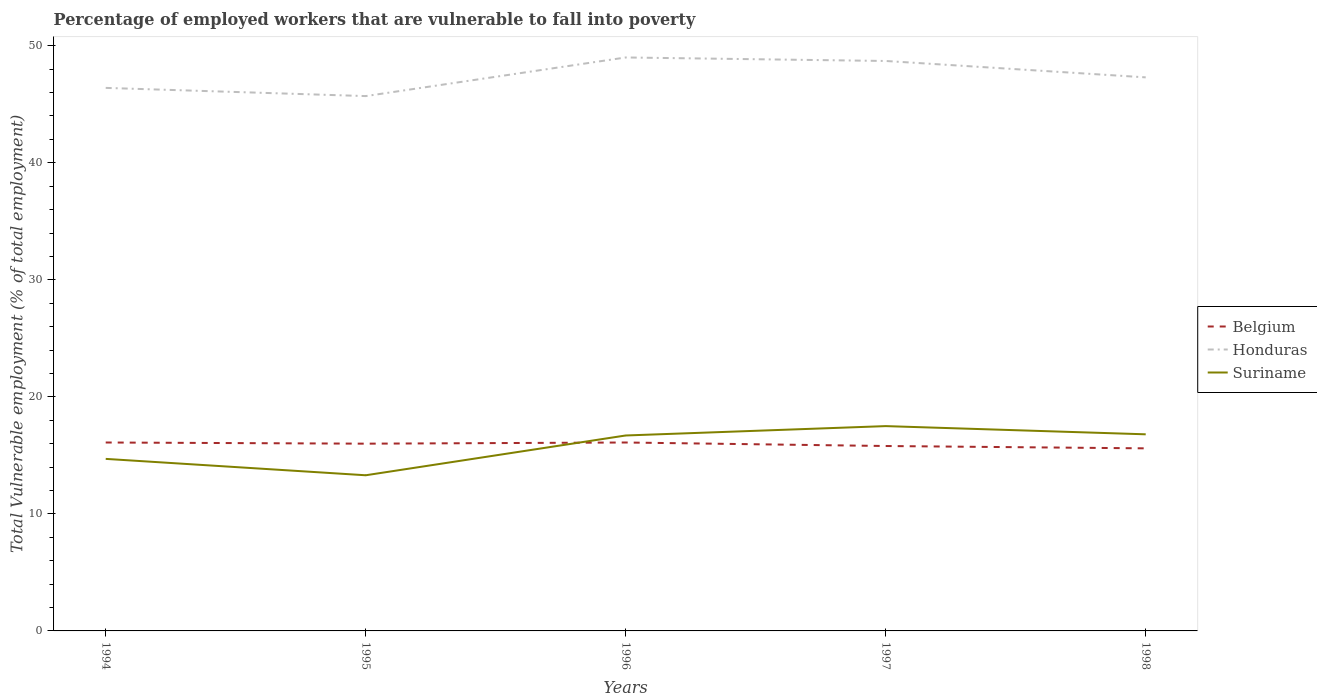How many different coloured lines are there?
Offer a terse response. 3. Is the number of lines equal to the number of legend labels?
Offer a very short reply. Yes. Across all years, what is the maximum percentage of employed workers who are vulnerable to fall into poverty in Belgium?
Give a very brief answer. 15.6. What is the total percentage of employed workers who are vulnerable to fall into poverty in Belgium in the graph?
Offer a terse response. 0.2. What is the difference between the highest and the second highest percentage of employed workers who are vulnerable to fall into poverty in Suriname?
Your response must be concise. 4.2. What is the difference between the highest and the lowest percentage of employed workers who are vulnerable to fall into poverty in Suriname?
Ensure brevity in your answer.  3. Is the percentage of employed workers who are vulnerable to fall into poverty in Suriname strictly greater than the percentage of employed workers who are vulnerable to fall into poverty in Honduras over the years?
Your answer should be compact. Yes. How many years are there in the graph?
Make the answer very short. 5. What is the difference between two consecutive major ticks on the Y-axis?
Provide a succinct answer. 10. Are the values on the major ticks of Y-axis written in scientific E-notation?
Give a very brief answer. No. Does the graph contain any zero values?
Offer a very short reply. No. Does the graph contain grids?
Your response must be concise. No. What is the title of the graph?
Give a very brief answer. Percentage of employed workers that are vulnerable to fall into poverty. Does "Turkmenistan" appear as one of the legend labels in the graph?
Ensure brevity in your answer.  No. What is the label or title of the Y-axis?
Offer a very short reply. Total Vulnerable employment (% of total employment). What is the Total Vulnerable employment (% of total employment) of Belgium in 1994?
Give a very brief answer. 16.1. What is the Total Vulnerable employment (% of total employment) of Honduras in 1994?
Give a very brief answer. 46.4. What is the Total Vulnerable employment (% of total employment) of Suriname in 1994?
Make the answer very short. 14.7. What is the Total Vulnerable employment (% of total employment) in Honduras in 1995?
Provide a succinct answer. 45.7. What is the Total Vulnerable employment (% of total employment) of Suriname in 1995?
Ensure brevity in your answer.  13.3. What is the Total Vulnerable employment (% of total employment) in Belgium in 1996?
Provide a short and direct response. 16.1. What is the Total Vulnerable employment (% of total employment) in Honduras in 1996?
Your answer should be compact. 49. What is the Total Vulnerable employment (% of total employment) of Suriname in 1996?
Make the answer very short. 16.7. What is the Total Vulnerable employment (% of total employment) of Belgium in 1997?
Your response must be concise. 15.8. What is the Total Vulnerable employment (% of total employment) of Honduras in 1997?
Ensure brevity in your answer.  48.7. What is the Total Vulnerable employment (% of total employment) of Belgium in 1998?
Keep it short and to the point. 15.6. What is the Total Vulnerable employment (% of total employment) of Honduras in 1998?
Your response must be concise. 47.3. What is the Total Vulnerable employment (% of total employment) in Suriname in 1998?
Offer a terse response. 16.8. Across all years, what is the maximum Total Vulnerable employment (% of total employment) in Belgium?
Provide a succinct answer. 16.1. Across all years, what is the maximum Total Vulnerable employment (% of total employment) in Honduras?
Provide a short and direct response. 49. Across all years, what is the minimum Total Vulnerable employment (% of total employment) in Belgium?
Your answer should be compact. 15.6. Across all years, what is the minimum Total Vulnerable employment (% of total employment) in Honduras?
Provide a succinct answer. 45.7. Across all years, what is the minimum Total Vulnerable employment (% of total employment) of Suriname?
Give a very brief answer. 13.3. What is the total Total Vulnerable employment (% of total employment) in Belgium in the graph?
Your answer should be very brief. 79.6. What is the total Total Vulnerable employment (% of total employment) in Honduras in the graph?
Make the answer very short. 237.1. What is the total Total Vulnerable employment (% of total employment) of Suriname in the graph?
Offer a terse response. 79. What is the difference between the Total Vulnerable employment (% of total employment) of Suriname in 1994 and that in 1995?
Offer a terse response. 1.4. What is the difference between the Total Vulnerable employment (% of total employment) of Belgium in 1994 and that in 1996?
Give a very brief answer. 0. What is the difference between the Total Vulnerable employment (% of total employment) in Suriname in 1994 and that in 1997?
Your response must be concise. -2.8. What is the difference between the Total Vulnerable employment (% of total employment) of Belgium in 1994 and that in 1998?
Keep it short and to the point. 0.5. What is the difference between the Total Vulnerable employment (% of total employment) in Honduras in 1995 and that in 1996?
Ensure brevity in your answer.  -3.3. What is the difference between the Total Vulnerable employment (% of total employment) of Suriname in 1995 and that in 1996?
Ensure brevity in your answer.  -3.4. What is the difference between the Total Vulnerable employment (% of total employment) of Belgium in 1995 and that in 1997?
Offer a terse response. 0.2. What is the difference between the Total Vulnerable employment (% of total employment) in Suriname in 1995 and that in 1997?
Offer a terse response. -4.2. What is the difference between the Total Vulnerable employment (% of total employment) in Belgium in 1996 and that in 1997?
Keep it short and to the point. 0.3. What is the difference between the Total Vulnerable employment (% of total employment) of Suriname in 1996 and that in 1997?
Your answer should be very brief. -0.8. What is the difference between the Total Vulnerable employment (% of total employment) of Belgium in 1996 and that in 1998?
Provide a succinct answer. 0.5. What is the difference between the Total Vulnerable employment (% of total employment) in Honduras in 1996 and that in 1998?
Provide a succinct answer. 1.7. What is the difference between the Total Vulnerable employment (% of total employment) of Suriname in 1996 and that in 1998?
Give a very brief answer. -0.1. What is the difference between the Total Vulnerable employment (% of total employment) of Honduras in 1997 and that in 1998?
Keep it short and to the point. 1.4. What is the difference between the Total Vulnerable employment (% of total employment) in Suriname in 1997 and that in 1998?
Give a very brief answer. 0.7. What is the difference between the Total Vulnerable employment (% of total employment) in Belgium in 1994 and the Total Vulnerable employment (% of total employment) in Honduras in 1995?
Provide a short and direct response. -29.6. What is the difference between the Total Vulnerable employment (% of total employment) in Belgium in 1994 and the Total Vulnerable employment (% of total employment) in Suriname in 1995?
Keep it short and to the point. 2.8. What is the difference between the Total Vulnerable employment (% of total employment) in Honduras in 1994 and the Total Vulnerable employment (% of total employment) in Suriname in 1995?
Make the answer very short. 33.1. What is the difference between the Total Vulnerable employment (% of total employment) of Belgium in 1994 and the Total Vulnerable employment (% of total employment) of Honduras in 1996?
Your response must be concise. -32.9. What is the difference between the Total Vulnerable employment (% of total employment) of Belgium in 1994 and the Total Vulnerable employment (% of total employment) of Suriname in 1996?
Ensure brevity in your answer.  -0.6. What is the difference between the Total Vulnerable employment (% of total employment) of Honduras in 1994 and the Total Vulnerable employment (% of total employment) of Suriname in 1996?
Keep it short and to the point. 29.7. What is the difference between the Total Vulnerable employment (% of total employment) in Belgium in 1994 and the Total Vulnerable employment (% of total employment) in Honduras in 1997?
Keep it short and to the point. -32.6. What is the difference between the Total Vulnerable employment (% of total employment) of Belgium in 1994 and the Total Vulnerable employment (% of total employment) of Suriname in 1997?
Provide a short and direct response. -1.4. What is the difference between the Total Vulnerable employment (% of total employment) of Honduras in 1994 and the Total Vulnerable employment (% of total employment) of Suriname in 1997?
Provide a succinct answer. 28.9. What is the difference between the Total Vulnerable employment (% of total employment) in Belgium in 1994 and the Total Vulnerable employment (% of total employment) in Honduras in 1998?
Offer a terse response. -31.2. What is the difference between the Total Vulnerable employment (% of total employment) in Honduras in 1994 and the Total Vulnerable employment (% of total employment) in Suriname in 1998?
Your answer should be compact. 29.6. What is the difference between the Total Vulnerable employment (% of total employment) of Belgium in 1995 and the Total Vulnerable employment (% of total employment) of Honduras in 1996?
Your answer should be compact. -33. What is the difference between the Total Vulnerable employment (% of total employment) in Belgium in 1995 and the Total Vulnerable employment (% of total employment) in Honduras in 1997?
Your response must be concise. -32.7. What is the difference between the Total Vulnerable employment (% of total employment) of Belgium in 1995 and the Total Vulnerable employment (% of total employment) of Suriname in 1997?
Provide a succinct answer. -1.5. What is the difference between the Total Vulnerable employment (% of total employment) in Honduras in 1995 and the Total Vulnerable employment (% of total employment) in Suriname in 1997?
Offer a very short reply. 28.2. What is the difference between the Total Vulnerable employment (% of total employment) in Belgium in 1995 and the Total Vulnerable employment (% of total employment) in Honduras in 1998?
Your response must be concise. -31.3. What is the difference between the Total Vulnerable employment (% of total employment) of Belgium in 1995 and the Total Vulnerable employment (% of total employment) of Suriname in 1998?
Ensure brevity in your answer.  -0.8. What is the difference between the Total Vulnerable employment (% of total employment) in Honduras in 1995 and the Total Vulnerable employment (% of total employment) in Suriname in 1998?
Keep it short and to the point. 28.9. What is the difference between the Total Vulnerable employment (% of total employment) in Belgium in 1996 and the Total Vulnerable employment (% of total employment) in Honduras in 1997?
Ensure brevity in your answer.  -32.6. What is the difference between the Total Vulnerable employment (% of total employment) of Belgium in 1996 and the Total Vulnerable employment (% of total employment) of Suriname in 1997?
Provide a succinct answer. -1.4. What is the difference between the Total Vulnerable employment (% of total employment) of Honduras in 1996 and the Total Vulnerable employment (% of total employment) of Suriname in 1997?
Your response must be concise. 31.5. What is the difference between the Total Vulnerable employment (% of total employment) of Belgium in 1996 and the Total Vulnerable employment (% of total employment) of Honduras in 1998?
Ensure brevity in your answer.  -31.2. What is the difference between the Total Vulnerable employment (% of total employment) in Honduras in 1996 and the Total Vulnerable employment (% of total employment) in Suriname in 1998?
Make the answer very short. 32.2. What is the difference between the Total Vulnerable employment (% of total employment) in Belgium in 1997 and the Total Vulnerable employment (% of total employment) in Honduras in 1998?
Ensure brevity in your answer.  -31.5. What is the difference between the Total Vulnerable employment (% of total employment) in Belgium in 1997 and the Total Vulnerable employment (% of total employment) in Suriname in 1998?
Provide a succinct answer. -1. What is the difference between the Total Vulnerable employment (% of total employment) in Honduras in 1997 and the Total Vulnerable employment (% of total employment) in Suriname in 1998?
Offer a terse response. 31.9. What is the average Total Vulnerable employment (% of total employment) in Belgium per year?
Your answer should be compact. 15.92. What is the average Total Vulnerable employment (% of total employment) in Honduras per year?
Give a very brief answer. 47.42. In the year 1994, what is the difference between the Total Vulnerable employment (% of total employment) in Belgium and Total Vulnerable employment (% of total employment) in Honduras?
Make the answer very short. -30.3. In the year 1994, what is the difference between the Total Vulnerable employment (% of total employment) in Belgium and Total Vulnerable employment (% of total employment) in Suriname?
Provide a short and direct response. 1.4. In the year 1994, what is the difference between the Total Vulnerable employment (% of total employment) in Honduras and Total Vulnerable employment (% of total employment) in Suriname?
Make the answer very short. 31.7. In the year 1995, what is the difference between the Total Vulnerable employment (% of total employment) of Belgium and Total Vulnerable employment (% of total employment) of Honduras?
Offer a very short reply. -29.7. In the year 1995, what is the difference between the Total Vulnerable employment (% of total employment) of Honduras and Total Vulnerable employment (% of total employment) of Suriname?
Ensure brevity in your answer.  32.4. In the year 1996, what is the difference between the Total Vulnerable employment (% of total employment) of Belgium and Total Vulnerable employment (% of total employment) of Honduras?
Offer a terse response. -32.9. In the year 1996, what is the difference between the Total Vulnerable employment (% of total employment) of Belgium and Total Vulnerable employment (% of total employment) of Suriname?
Offer a very short reply. -0.6. In the year 1996, what is the difference between the Total Vulnerable employment (% of total employment) of Honduras and Total Vulnerable employment (% of total employment) of Suriname?
Give a very brief answer. 32.3. In the year 1997, what is the difference between the Total Vulnerable employment (% of total employment) in Belgium and Total Vulnerable employment (% of total employment) in Honduras?
Your answer should be very brief. -32.9. In the year 1997, what is the difference between the Total Vulnerable employment (% of total employment) in Belgium and Total Vulnerable employment (% of total employment) in Suriname?
Provide a short and direct response. -1.7. In the year 1997, what is the difference between the Total Vulnerable employment (% of total employment) in Honduras and Total Vulnerable employment (% of total employment) in Suriname?
Give a very brief answer. 31.2. In the year 1998, what is the difference between the Total Vulnerable employment (% of total employment) in Belgium and Total Vulnerable employment (% of total employment) in Honduras?
Offer a very short reply. -31.7. In the year 1998, what is the difference between the Total Vulnerable employment (% of total employment) of Belgium and Total Vulnerable employment (% of total employment) of Suriname?
Offer a terse response. -1.2. In the year 1998, what is the difference between the Total Vulnerable employment (% of total employment) in Honduras and Total Vulnerable employment (% of total employment) in Suriname?
Your answer should be compact. 30.5. What is the ratio of the Total Vulnerable employment (% of total employment) in Belgium in 1994 to that in 1995?
Your answer should be very brief. 1.01. What is the ratio of the Total Vulnerable employment (% of total employment) of Honduras in 1994 to that in 1995?
Provide a short and direct response. 1.02. What is the ratio of the Total Vulnerable employment (% of total employment) in Suriname in 1994 to that in 1995?
Provide a succinct answer. 1.11. What is the ratio of the Total Vulnerable employment (% of total employment) in Honduras in 1994 to that in 1996?
Make the answer very short. 0.95. What is the ratio of the Total Vulnerable employment (% of total employment) in Suriname in 1994 to that in 1996?
Your answer should be compact. 0.88. What is the ratio of the Total Vulnerable employment (% of total employment) in Belgium in 1994 to that in 1997?
Give a very brief answer. 1.02. What is the ratio of the Total Vulnerable employment (% of total employment) of Honduras in 1994 to that in 1997?
Your answer should be compact. 0.95. What is the ratio of the Total Vulnerable employment (% of total employment) of Suriname in 1994 to that in 1997?
Provide a short and direct response. 0.84. What is the ratio of the Total Vulnerable employment (% of total employment) in Belgium in 1994 to that in 1998?
Your answer should be compact. 1.03. What is the ratio of the Total Vulnerable employment (% of total employment) in Honduras in 1994 to that in 1998?
Ensure brevity in your answer.  0.98. What is the ratio of the Total Vulnerable employment (% of total employment) of Honduras in 1995 to that in 1996?
Provide a succinct answer. 0.93. What is the ratio of the Total Vulnerable employment (% of total employment) of Suriname in 1995 to that in 1996?
Your answer should be very brief. 0.8. What is the ratio of the Total Vulnerable employment (% of total employment) in Belgium in 1995 to that in 1997?
Provide a succinct answer. 1.01. What is the ratio of the Total Vulnerable employment (% of total employment) in Honduras in 1995 to that in 1997?
Provide a succinct answer. 0.94. What is the ratio of the Total Vulnerable employment (% of total employment) of Suriname in 1995 to that in 1997?
Your answer should be very brief. 0.76. What is the ratio of the Total Vulnerable employment (% of total employment) of Belgium in 1995 to that in 1998?
Your answer should be compact. 1.03. What is the ratio of the Total Vulnerable employment (% of total employment) in Honduras in 1995 to that in 1998?
Give a very brief answer. 0.97. What is the ratio of the Total Vulnerable employment (% of total employment) of Suriname in 1995 to that in 1998?
Provide a short and direct response. 0.79. What is the ratio of the Total Vulnerable employment (% of total employment) in Belgium in 1996 to that in 1997?
Your answer should be compact. 1.02. What is the ratio of the Total Vulnerable employment (% of total employment) in Honduras in 1996 to that in 1997?
Make the answer very short. 1.01. What is the ratio of the Total Vulnerable employment (% of total employment) in Suriname in 1996 to that in 1997?
Provide a short and direct response. 0.95. What is the ratio of the Total Vulnerable employment (% of total employment) in Belgium in 1996 to that in 1998?
Keep it short and to the point. 1.03. What is the ratio of the Total Vulnerable employment (% of total employment) in Honduras in 1996 to that in 1998?
Provide a short and direct response. 1.04. What is the ratio of the Total Vulnerable employment (% of total employment) of Belgium in 1997 to that in 1998?
Your answer should be very brief. 1.01. What is the ratio of the Total Vulnerable employment (% of total employment) in Honduras in 1997 to that in 1998?
Give a very brief answer. 1.03. What is the ratio of the Total Vulnerable employment (% of total employment) of Suriname in 1997 to that in 1998?
Make the answer very short. 1.04. What is the difference between the highest and the second highest Total Vulnerable employment (% of total employment) of Belgium?
Provide a succinct answer. 0. What is the difference between the highest and the lowest Total Vulnerable employment (% of total employment) of Honduras?
Give a very brief answer. 3.3. 